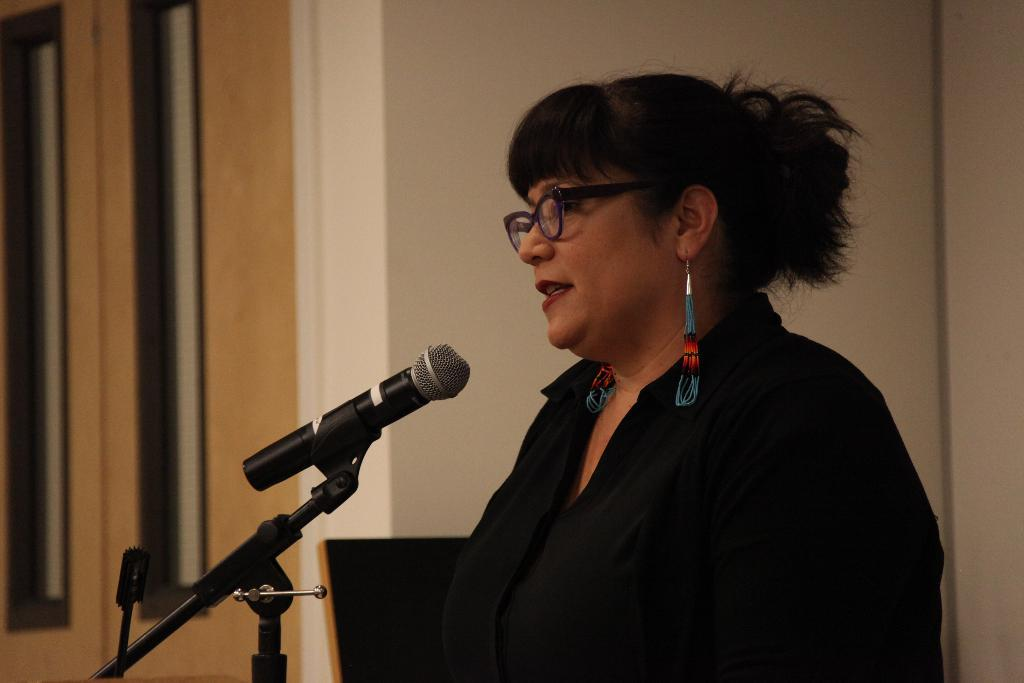What is the person in the image doing? The person is standing in front of a mic. What is the person wearing? The person is wearing a black dress and specs. What can be seen in the background of the image? There is a wall visible in the background. What type of amusement can be seen in the image? There is no amusement present in the image; it features a person standing in front of a mic. What kind of badge is the person wearing in the image? The person is not wearing a badge in the image. 